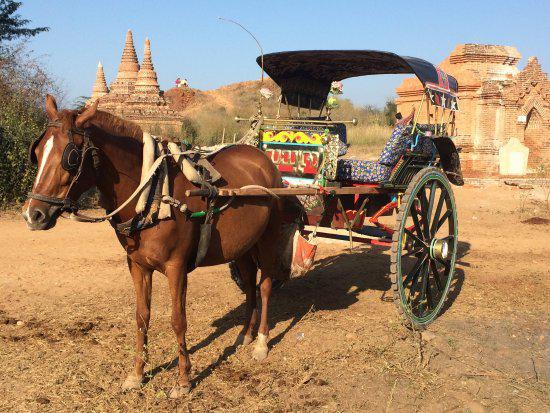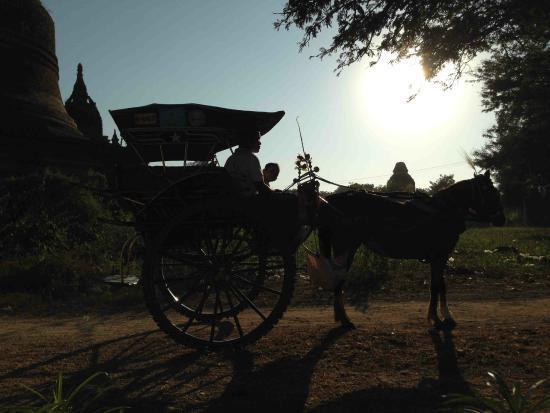The first image is the image on the left, the second image is the image on the right. Examine the images to the left and right. Is the description "The right image shows a passenger in a two-wheeled horse-drawn cart, and the left image shows a passenger-less two-wheeled cart hitched to a horse." accurate? Answer yes or no. Yes. The first image is the image on the left, the second image is the image on the right. Analyze the images presented: Is the assertion "The left and right image contains the same number of horses pulling a cart in different directions." valid? Answer yes or no. Yes. 